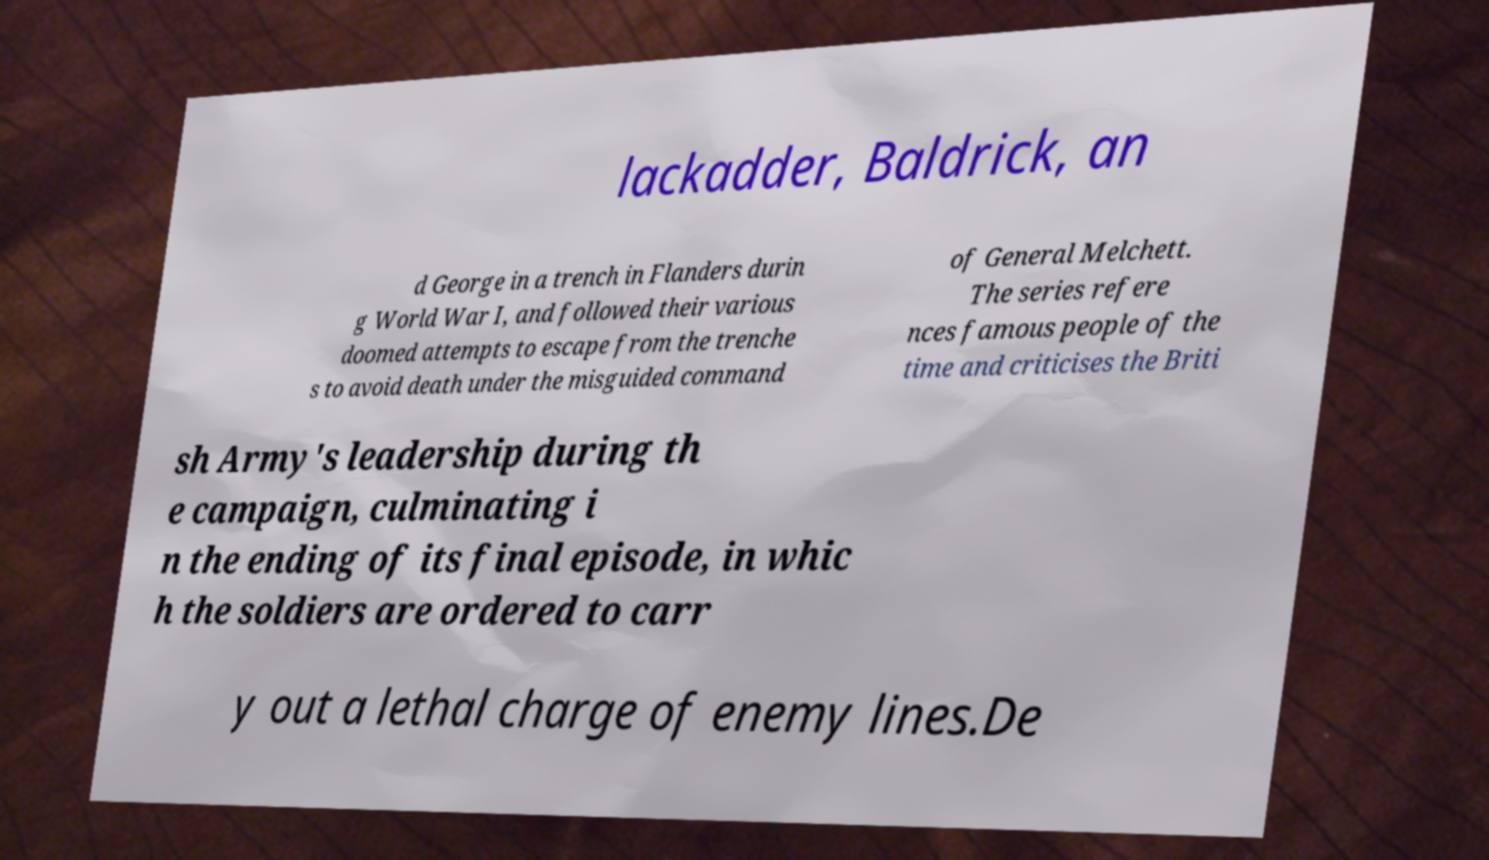Could you assist in decoding the text presented in this image and type it out clearly? lackadder, Baldrick, an d George in a trench in Flanders durin g World War I, and followed their various doomed attempts to escape from the trenche s to avoid death under the misguided command of General Melchett. The series refere nces famous people of the time and criticises the Briti sh Army's leadership during th e campaign, culminating i n the ending of its final episode, in whic h the soldiers are ordered to carr y out a lethal charge of enemy lines.De 